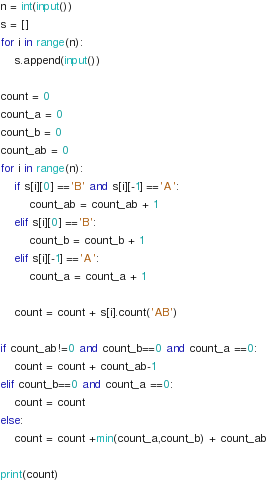<code> <loc_0><loc_0><loc_500><loc_500><_Python_>n = int(input())
s = []
for i in range(n):
    s.append(input())

count = 0
count_a = 0
count_b = 0
count_ab = 0
for i in range(n):
    if s[i][0] =='B' and s[i][-1] =='A':
        count_ab = count_ab + 1
    elif s[i][0] =='B':
        count_b = count_b + 1
    elif s[i][-1] =='A':
        count_a = count_a + 1
    
    count = count + s[i].count('AB')

if count_ab!=0 and count_b==0 and count_a ==0:
    count = count + count_ab-1
elif count_b==0 and count_a ==0:
    count = count
else:
    count = count +min(count_a,count_b) + count_ab

print(count)</code> 